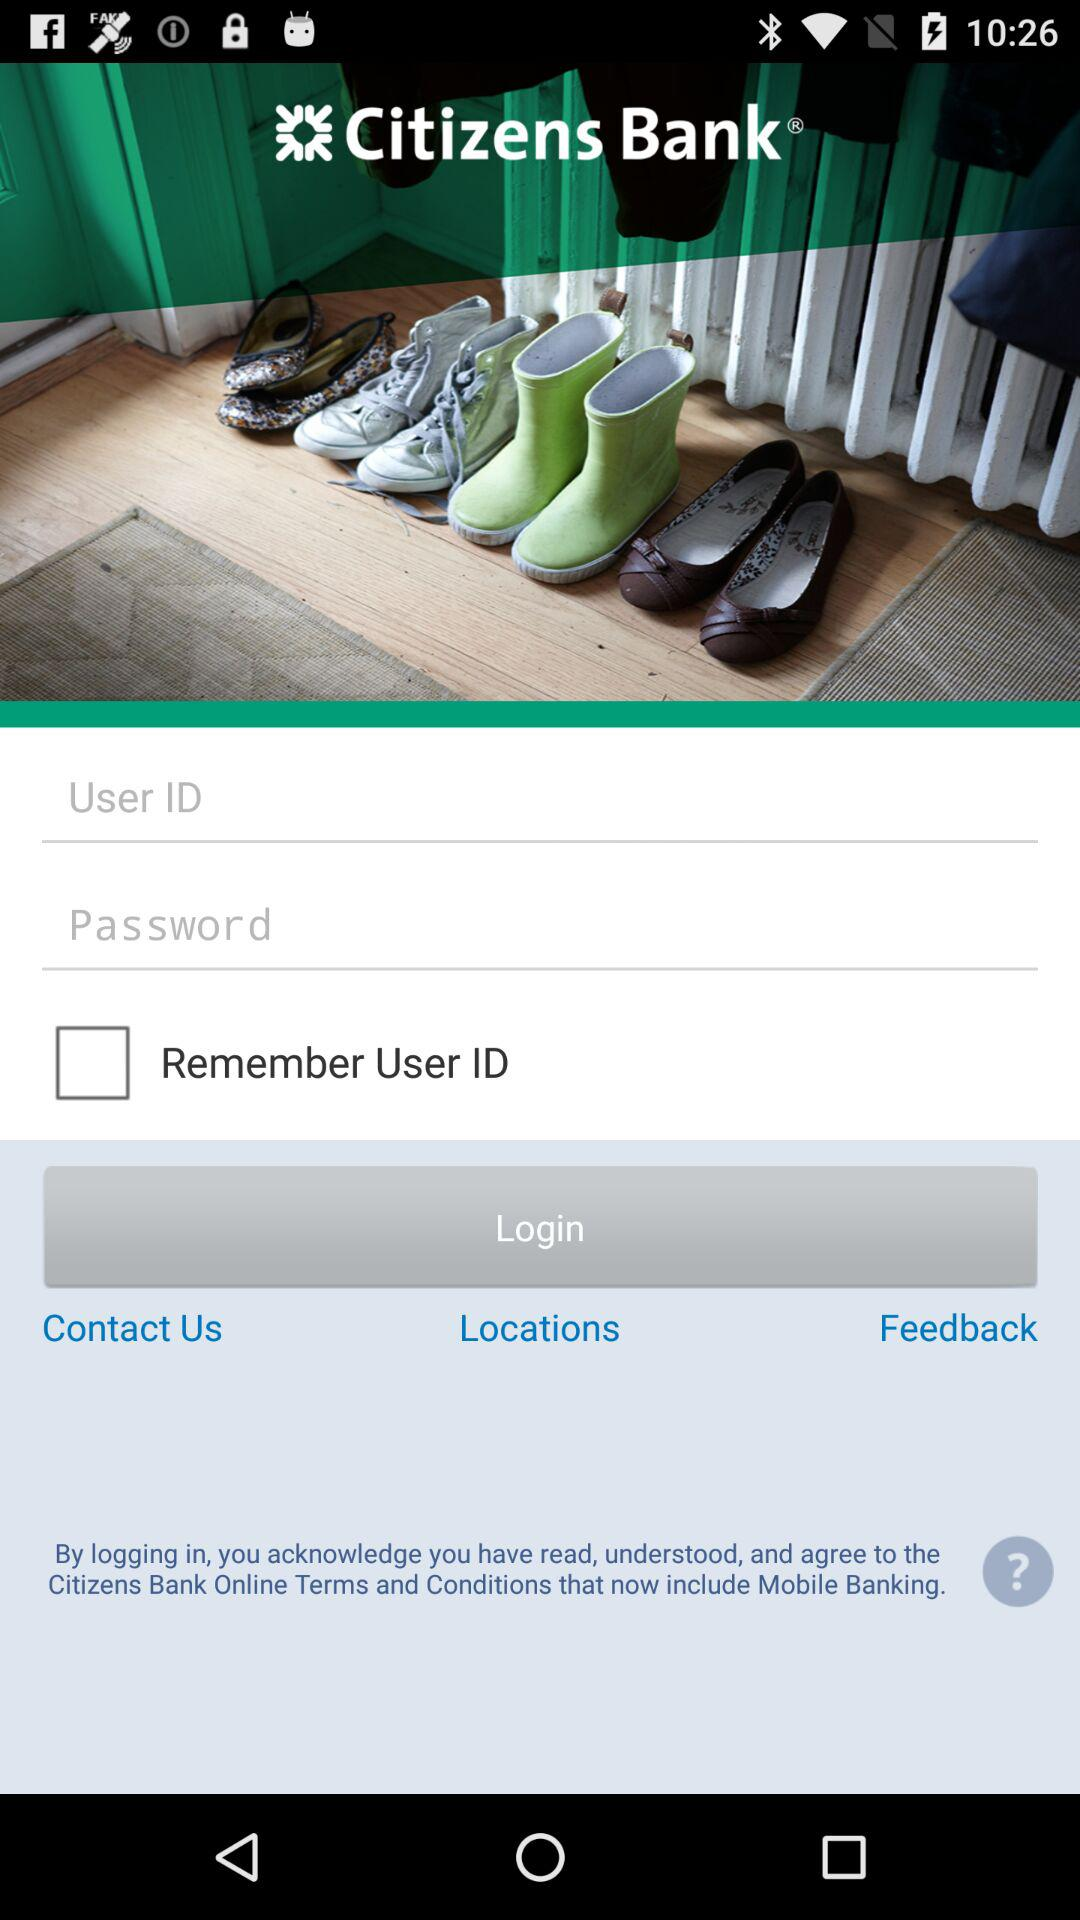What is the application name? The application name is "Citizens Bank". 